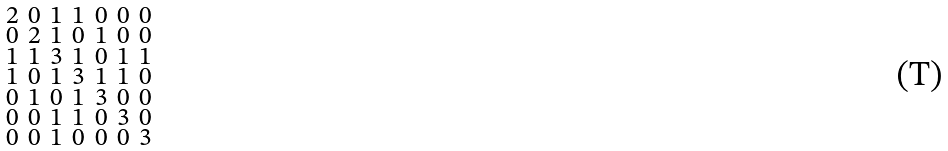<formula> <loc_0><loc_0><loc_500><loc_500>\begin{smallmatrix} 2 & 0 & 1 & 1 & 0 & 0 & 0 \\ 0 & 2 & 1 & 0 & 1 & 0 & 0 \\ 1 & 1 & 3 & 1 & 0 & 1 & 1 \\ 1 & 0 & 1 & 3 & 1 & 1 & 0 \\ 0 & 1 & 0 & 1 & 3 & 0 & 0 \\ 0 & 0 & 1 & 1 & 0 & 3 & 0 \\ 0 & 0 & 1 & 0 & 0 & 0 & 3 \end{smallmatrix}</formula> 